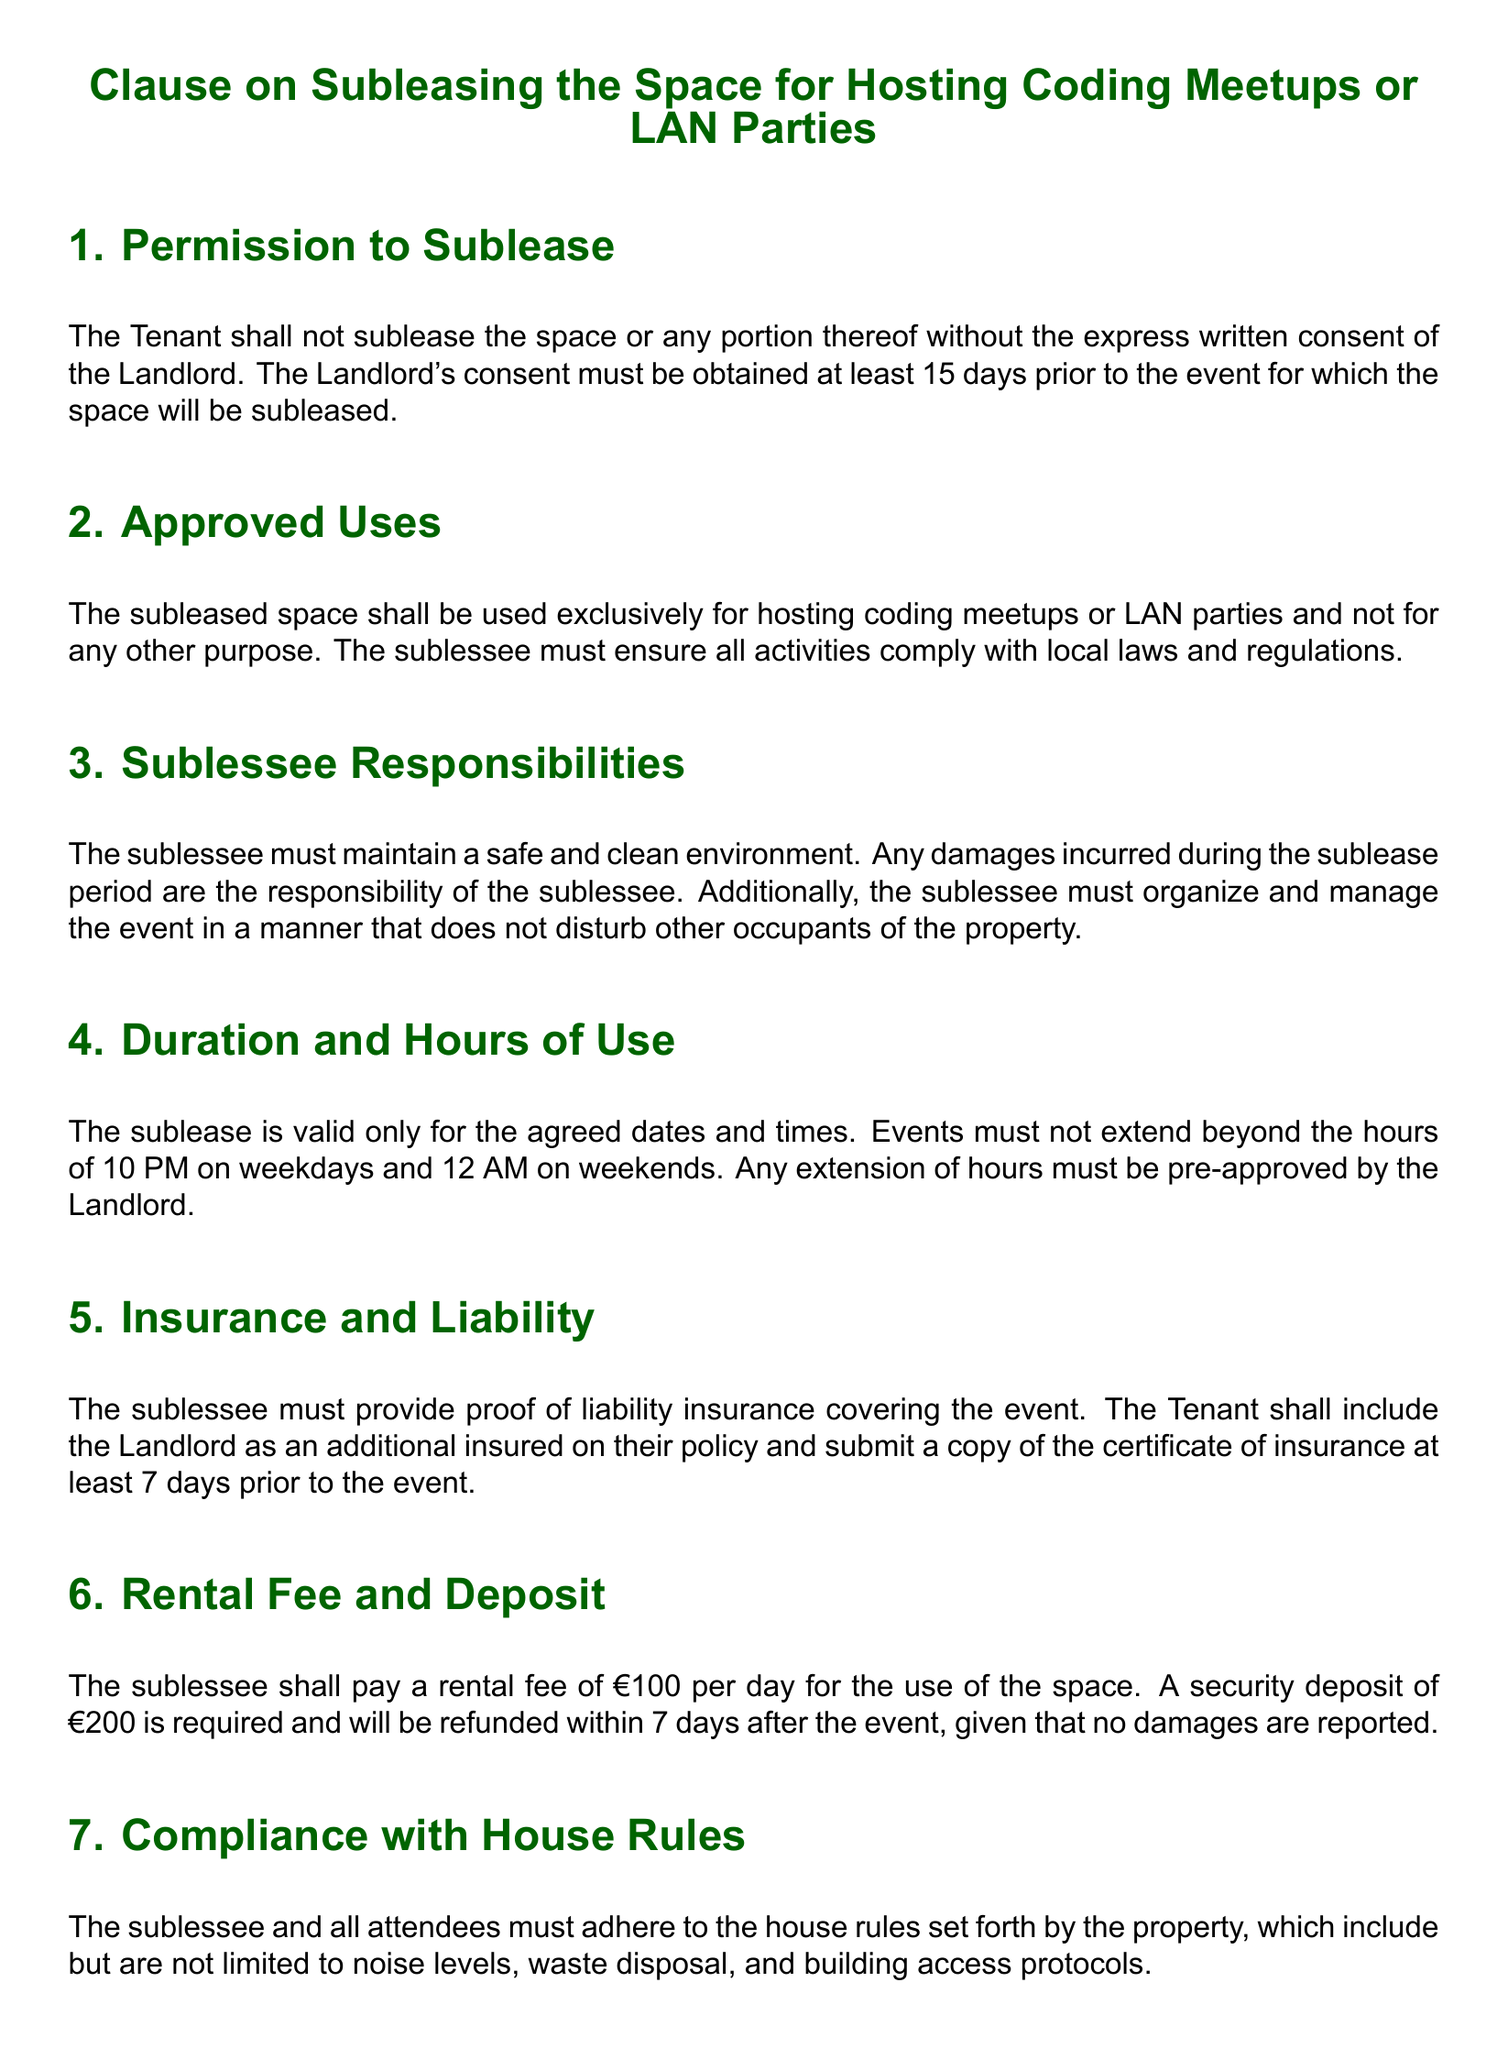What is required for the Tenant to sublease the space? The Tenant must obtain the express written consent of the Landlord.
Answer: express written consent How many days in advance must consent be obtained? The document states that consent must be obtained at least 15 days prior to the event.
Answer: 15 days What is the rental fee per day for using the space? The rental fee for the use of the space is specified as €100 per day.
Answer: €100 What is the security deposit amount? The document mentions that a security deposit of €200 is required.
Answer: €200 What hours must events not extend beyond on weekdays? The document specifies that events must not extend beyond the hours of 10 PM on weekdays.
Answer: 10 PM What must the sublessee provide proof of? The sublessee must provide proof of liability insurance covering the event.
Answer: liability insurance Which party is entitled to terminate the sublease if illegal activity is reported? The Landlord reserves the right to terminate the sublease without notice.
Answer: Landlord What type of activities can the subleased space be used for? The subleased space is exclusively for hosting coding meetups or LAN parties.
Answer: coding meetups or LAN parties 